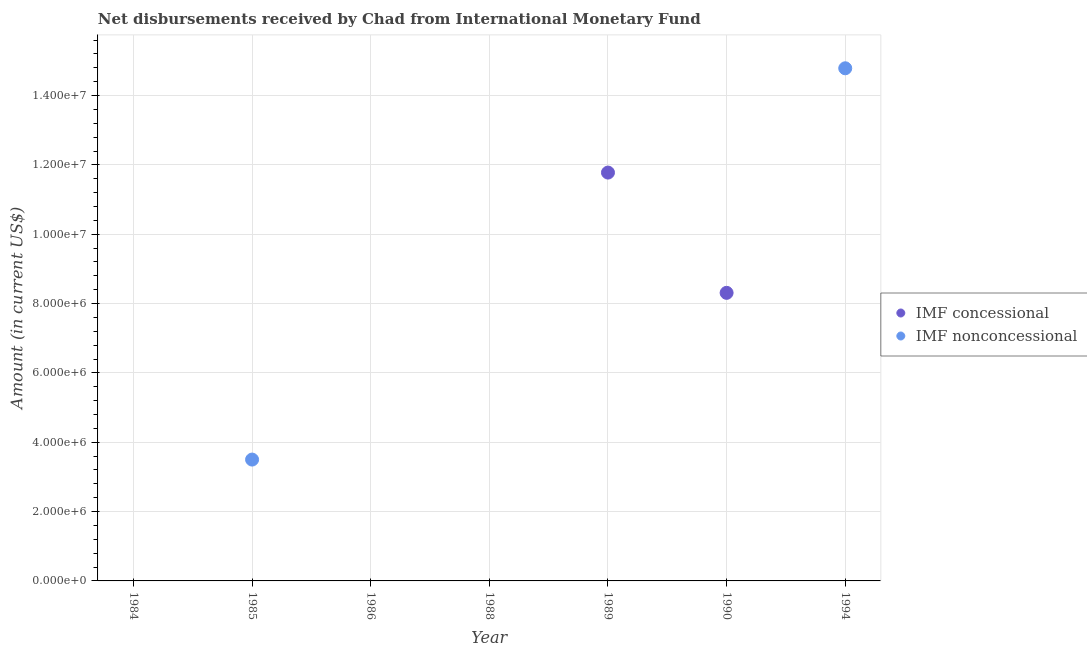How many different coloured dotlines are there?
Ensure brevity in your answer.  2. Across all years, what is the maximum net concessional disbursements from imf?
Your answer should be compact. 1.18e+07. In which year was the net concessional disbursements from imf maximum?
Your answer should be very brief. 1989. What is the total net non concessional disbursements from imf in the graph?
Offer a terse response. 1.83e+07. What is the average net non concessional disbursements from imf per year?
Your answer should be very brief. 2.61e+06. Is the net concessional disbursements from imf in 1989 less than that in 1990?
Provide a short and direct response. No. What is the difference between the highest and the lowest net concessional disbursements from imf?
Your answer should be compact. 1.18e+07. Does the net non concessional disbursements from imf monotonically increase over the years?
Provide a short and direct response. No. Is the net concessional disbursements from imf strictly greater than the net non concessional disbursements from imf over the years?
Provide a short and direct response. No. Is the net non concessional disbursements from imf strictly less than the net concessional disbursements from imf over the years?
Offer a very short reply. No. Are the values on the major ticks of Y-axis written in scientific E-notation?
Offer a terse response. Yes. Does the graph contain grids?
Your response must be concise. Yes. Where does the legend appear in the graph?
Ensure brevity in your answer.  Center right. How are the legend labels stacked?
Your answer should be compact. Vertical. What is the title of the graph?
Provide a short and direct response. Net disbursements received by Chad from International Monetary Fund. What is the Amount (in current US$) in IMF concessional in 1984?
Offer a terse response. 0. What is the Amount (in current US$) of IMF nonconcessional in 1985?
Offer a terse response. 3.50e+06. What is the Amount (in current US$) of IMF concessional in 1986?
Make the answer very short. 0. What is the Amount (in current US$) in IMF concessional in 1988?
Give a very brief answer. 0. What is the Amount (in current US$) in IMF nonconcessional in 1988?
Provide a succinct answer. 0. What is the Amount (in current US$) of IMF concessional in 1989?
Ensure brevity in your answer.  1.18e+07. What is the Amount (in current US$) in IMF nonconcessional in 1989?
Offer a terse response. 0. What is the Amount (in current US$) of IMF concessional in 1990?
Ensure brevity in your answer.  8.31e+06. What is the Amount (in current US$) in IMF concessional in 1994?
Offer a very short reply. 0. What is the Amount (in current US$) in IMF nonconcessional in 1994?
Keep it short and to the point. 1.48e+07. Across all years, what is the maximum Amount (in current US$) in IMF concessional?
Your answer should be very brief. 1.18e+07. Across all years, what is the maximum Amount (in current US$) of IMF nonconcessional?
Offer a terse response. 1.48e+07. What is the total Amount (in current US$) in IMF concessional in the graph?
Your answer should be compact. 2.01e+07. What is the total Amount (in current US$) of IMF nonconcessional in the graph?
Ensure brevity in your answer.  1.83e+07. What is the difference between the Amount (in current US$) of IMF nonconcessional in 1985 and that in 1994?
Make the answer very short. -1.13e+07. What is the difference between the Amount (in current US$) of IMF concessional in 1989 and that in 1990?
Provide a short and direct response. 3.47e+06. What is the difference between the Amount (in current US$) of IMF concessional in 1989 and the Amount (in current US$) of IMF nonconcessional in 1994?
Your answer should be compact. -3.01e+06. What is the difference between the Amount (in current US$) in IMF concessional in 1990 and the Amount (in current US$) in IMF nonconcessional in 1994?
Your answer should be compact. -6.48e+06. What is the average Amount (in current US$) in IMF concessional per year?
Your answer should be compact. 2.87e+06. What is the average Amount (in current US$) in IMF nonconcessional per year?
Ensure brevity in your answer.  2.61e+06. What is the ratio of the Amount (in current US$) in IMF nonconcessional in 1985 to that in 1994?
Give a very brief answer. 0.24. What is the ratio of the Amount (in current US$) of IMF concessional in 1989 to that in 1990?
Keep it short and to the point. 1.42. What is the difference between the highest and the lowest Amount (in current US$) of IMF concessional?
Offer a very short reply. 1.18e+07. What is the difference between the highest and the lowest Amount (in current US$) in IMF nonconcessional?
Your answer should be very brief. 1.48e+07. 